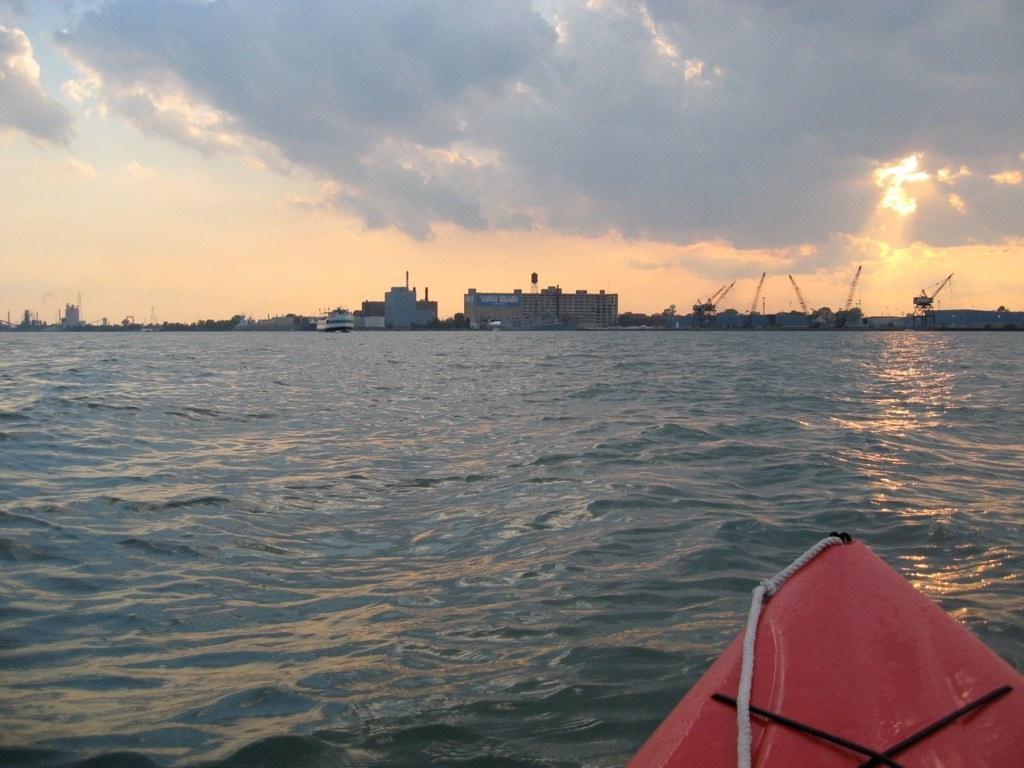Please provide a concise description of this image. In the foreground of the picture there is a boat and water. In the center of the picture there are buildings, trees and cranes. On the left those are sun rays. Sky is cloudy. 